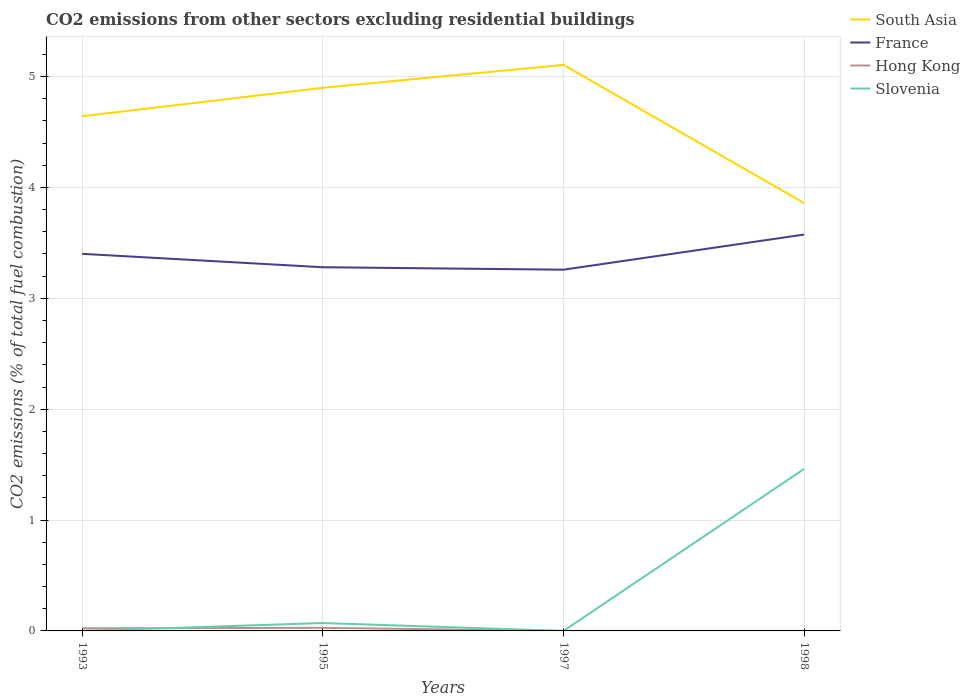How many different coloured lines are there?
Provide a succinct answer. 4. Does the line corresponding to Slovenia intersect with the line corresponding to South Asia?
Provide a short and direct response. No. Is the number of lines equal to the number of legend labels?
Provide a short and direct response. No. Across all years, what is the maximum total CO2 emitted in South Asia?
Provide a short and direct response. 3.86. What is the total total CO2 emitted in France in the graph?
Offer a very short reply. 0.14. What is the difference between the highest and the second highest total CO2 emitted in Slovenia?
Offer a very short reply. 1.46. Is the total CO2 emitted in South Asia strictly greater than the total CO2 emitted in Hong Kong over the years?
Your response must be concise. No. How many lines are there?
Ensure brevity in your answer.  4. How many years are there in the graph?
Offer a terse response. 4. How are the legend labels stacked?
Make the answer very short. Vertical. What is the title of the graph?
Your response must be concise. CO2 emissions from other sectors excluding residential buildings. What is the label or title of the Y-axis?
Your response must be concise. CO2 emissions (% of total fuel combustion). What is the CO2 emissions (% of total fuel combustion) in South Asia in 1993?
Your answer should be compact. 4.64. What is the CO2 emissions (% of total fuel combustion) of France in 1993?
Keep it short and to the point. 3.4. What is the CO2 emissions (% of total fuel combustion) of Hong Kong in 1993?
Your answer should be very brief. 0.02. What is the CO2 emissions (% of total fuel combustion) in Slovenia in 1993?
Provide a succinct answer. 8.47498492080272e-16. What is the CO2 emissions (% of total fuel combustion) of South Asia in 1995?
Make the answer very short. 4.9. What is the CO2 emissions (% of total fuel combustion) in France in 1995?
Offer a very short reply. 3.28. What is the CO2 emissions (% of total fuel combustion) in Hong Kong in 1995?
Your answer should be very brief. 0.03. What is the CO2 emissions (% of total fuel combustion) of Slovenia in 1995?
Keep it short and to the point. 0.07. What is the CO2 emissions (% of total fuel combustion) of South Asia in 1997?
Your response must be concise. 5.11. What is the CO2 emissions (% of total fuel combustion) of France in 1997?
Give a very brief answer. 3.26. What is the CO2 emissions (% of total fuel combustion) of Hong Kong in 1997?
Ensure brevity in your answer.  0. What is the CO2 emissions (% of total fuel combustion) in Slovenia in 1997?
Your response must be concise. 0. What is the CO2 emissions (% of total fuel combustion) in South Asia in 1998?
Your response must be concise. 3.86. What is the CO2 emissions (% of total fuel combustion) of France in 1998?
Your answer should be very brief. 3.58. What is the CO2 emissions (% of total fuel combustion) of Hong Kong in 1998?
Make the answer very short. 0. What is the CO2 emissions (% of total fuel combustion) of Slovenia in 1998?
Provide a succinct answer. 1.46. Across all years, what is the maximum CO2 emissions (% of total fuel combustion) in South Asia?
Make the answer very short. 5.11. Across all years, what is the maximum CO2 emissions (% of total fuel combustion) in France?
Offer a very short reply. 3.58. Across all years, what is the maximum CO2 emissions (% of total fuel combustion) in Hong Kong?
Your answer should be very brief. 0.03. Across all years, what is the maximum CO2 emissions (% of total fuel combustion) of Slovenia?
Give a very brief answer. 1.46. Across all years, what is the minimum CO2 emissions (% of total fuel combustion) of South Asia?
Your response must be concise. 3.86. Across all years, what is the minimum CO2 emissions (% of total fuel combustion) in France?
Your answer should be very brief. 3.26. What is the total CO2 emissions (% of total fuel combustion) in South Asia in the graph?
Offer a very short reply. 18.51. What is the total CO2 emissions (% of total fuel combustion) in France in the graph?
Keep it short and to the point. 13.51. What is the total CO2 emissions (% of total fuel combustion) in Hong Kong in the graph?
Offer a terse response. 0.05. What is the total CO2 emissions (% of total fuel combustion) of Slovenia in the graph?
Make the answer very short. 1.53. What is the difference between the CO2 emissions (% of total fuel combustion) of South Asia in 1993 and that in 1995?
Offer a very short reply. -0.26. What is the difference between the CO2 emissions (% of total fuel combustion) of France in 1993 and that in 1995?
Ensure brevity in your answer.  0.12. What is the difference between the CO2 emissions (% of total fuel combustion) of Hong Kong in 1993 and that in 1995?
Offer a very short reply. -0. What is the difference between the CO2 emissions (% of total fuel combustion) in Slovenia in 1993 and that in 1995?
Your response must be concise. -0.07. What is the difference between the CO2 emissions (% of total fuel combustion) in South Asia in 1993 and that in 1997?
Your answer should be very brief. -0.46. What is the difference between the CO2 emissions (% of total fuel combustion) in France in 1993 and that in 1997?
Provide a succinct answer. 0.14. What is the difference between the CO2 emissions (% of total fuel combustion) of South Asia in 1993 and that in 1998?
Offer a terse response. 0.78. What is the difference between the CO2 emissions (% of total fuel combustion) in France in 1993 and that in 1998?
Offer a very short reply. -0.17. What is the difference between the CO2 emissions (% of total fuel combustion) of Slovenia in 1993 and that in 1998?
Your answer should be very brief. -1.46. What is the difference between the CO2 emissions (% of total fuel combustion) in South Asia in 1995 and that in 1997?
Offer a very short reply. -0.21. What is the difference between the CO2 emissions (% of total fuel combustion) in France in 1995 and that in 1997?
Keep it short and to the point. 0.02. What is the difference between the CO2 emissions (% of total fuel combustion) in South Asia in 1995 and that in 1998?
Provide a short and direct response. 1.04. What is the difference between the CO2 emissions (% of total fuel combustion) in France in 1995 and that in 1998?
Provide a succinct answer. -0.29. What is the difference between the CO2 emissions (% of total fuel combustion) of Slovenia in 1995 and that in 1998?
Keep it short and to the point. -1.39. What is the difference between the CO2 emissions (% of total fuel combustion) in South Asia in 1997 and that in 1998?
Your answer should be compact. 1.25. What is the difference between the CO2 emissions (% of total fuel combustion) of France in 1997 and that in 1998?
Keep it short and to the point. -0.32. What is the difference between the CO2 emissions (% of total fuel combustion) in South Asia in 1993 and the CO2 emissions (% of total fuel combustion) in France in 1995?
Your answer should be very brief. 1.36. What is the difference between the CO2 emissions (% of total fuel combustion) of South Asia in 1993 and the CO2 emissions (% of total fuel combustion) of Hong Kong in 1995?
Your response must be concise. 4.61. What is the difference between the CO2 emissions (% of total fuel combustion) of South Asia in 1993 and the CO2 emissions (% of total fuel combustion) of Slovenia in 1995?
Offer a terse response. 4.57. What is the difference between the CO2 emissions (% of total fuel combustion) in France in 1993 and the CO2 emissions (% of total fuel combustion) in Hong Kong in 1995?
Keep it short and to the point. 3.37. What is the difference between the CO2 emissions (% of total fuel combustion) of France in 1993 and the CO2 emissions (% of total fuel combustion) of Slovenia in 1995?
Provide a succinct answer. 3.33. What is the difference between the CO2 emissions (% of total fuel combustion) in Hong Kong in 1993 and the CO2 emissions (% of total fuel combustion) in Slovenia in 1995?
Provide a succinct answer. -0.05. What is the difference between the CO2 emissions (% of total fuel combustion) of South Asia in 1993 and the CO2 emissions (% of total fuel combustion) of France in 1997?
Give a very brief answer. 1.38. What is the difference between the CO2 emissions (% of total fuel combustion) of South Asia in 1993 and the CO2 emissions (% of total fuel combustion) of France in 1998?
Provide a short and direct response. 1.07. What is the difference between the CO2 emissions (% of total fuel combustion) in South Asia in 1993 and the CO2 emissions (% of total fuel combustion) in Slovenia in 1998?
Offer a very short reply. 3.18. What is the difference between the CO2 emissions (% of total fuel combustion) of France in 1993 and the CO2 emissions (% of total fuel combustion) of Slovenia in 1998?
Make the answer very short. 1.94. What is the difference between the CO2 emissions (% of total fuel combustion) of Hong Kong in 1993 and the CO2 emissions (% of total fuel combustion) of Slovenia in 1998?
Offer a very short reply. -1.44. What is the difference between the CO2 emissions (% of total fuel combustion) of South Asia in 1995 and the CO2 emissions (% of total fuel combustion) of France in 1997?
Offer a terse response. 1.64. What is the difference between the CO2 emissions (% of total fuel combustion) of South Asia in 1995 and the CO2 emissions (% of total fuel combustion) of France in 1998?
Offer a very short reply. 1.32. What is the difference between the CO2 emissions (% of total fuel combustion) of South Asia in 1995 and the CO2 emissions (% of total fuel combustion) of Slovenia in 1998?
Provide a short and direct response. 3.44. What is the difference between the CO2 emissions (% of total fuel combustion) of France in 1995 and the CO2 emissions (% of total fuel combustion) of Slovenia in 1998?
Provide a succinct answer. 1.82. What is the difference between the CO2 emissions (% of total fuel combustion) in Hong Kong in 1995 and the CO2 emissions (% of total fuel combustion) in Slovenia in 1998?
Your response must be concise. -1.43. What is the difference between the CO2 emissions (% of total fuel combustion) in South Asia in 1997 and the CO2 emissions (% of total fuel combustion) in France in 1998?
Your response must be concise. 1.53. What is the difference between the CO2 emissions (% of total fuel combustion) in South Asia in 1997 and the CO2 emissions (% of total fuel combustion) in Slovenia in 1998?
Your answer should be very brief. 3.64. What is the difference between the CO2 emissions (% of total fuel combustion) in France in 1997 and the CO2 emissions (% of total fuel combustion) in Slovenia in 1998?
Provide a short and direct response. 1.8. What is the average CO2 emissions (% of total fuel combustion) in South Asia per year?
Offer a very short reply. 4.63. What is the average CO2 emissions (% of total fuel combustion) of France per year?
Your answer should be compact. 3.38. What is the average CO2 emissions (% of total fuel combustion) in Hong Kong per year?
Provide a short and direct response. 0.01. What is the average CO2 emissions (% of total fuel combustion) in Slovenia per year?
Keep it short and to the point. 0.38. In the year 1993, what is the difference between the CO2 emissions (% of total fuel combustion) in South Asia and CO2 emissions (% of total fuel combustion) in France?
Make the answer very short. 1.24. In the year 1993, what is the difference between the CO2 emissions (% of total fuel combustion) in South Asia and CO2 emissions (% of total fuel combustion) in Hong Kong?
Offer a very short reply. 4.62. In the year 1993, what is the difference between the CO2 emissions (% of total fuel combustion) in South Asia and CO2 emissions (% of total fuel combustion) in Slovenia?
Your answer should be compact. 4.64. In the year 1993, what is the difference between the CO2 emissions (% of total fuel combustion) in France and CO2 emissions (% of total fuel combustion) in Hong Kong?
Offer a very short reply. 3.38. In the year 1993, what is the difference between the CO2 emissions (% of total fuel combustion) in France and CO2 emissions (% of total fuel combustion) in Slovenia?
Provide a succinct answer. 3.4. In the year 1993, what is the difference between the CO2 emissions (% of total fuel combustion) in Hong Kong and CO2 emissions (% of total fuel combustion) in Slovenia?
Keep it short and to the point. 0.02. In the year 1995, what is the difference between the CO2 emissions (% of total fuel combustion) in South Asia and CO2 emissions (% of total fuel combustion) in France?
Ensure brevity in your answer.  1.62. In the year 1995, what is the difference between the CO2 emissions (% of total fuel combustion) in South Asia and CO2 emissions (% of total fuel combustion) in Hong Kong?
Offer a very short reply. 4.87. In the year 1995, what is the difference between the CO2 emissions (% of total fuel combustion) of South Asia and CO2 emissions (% of total fuel combustion) of Slovenia?
Provide a succinct answer. 4.83. In the year 1995, what is the difference between the CO2 emissions (% of total fuel combustion) of France and CO2 emissions (% of total fuel combustion) of Hong Kong?
Your answer should be very brief. 3.25. In the year 1995, what is the difference between the CO2 emissions (% of total fuel combustion) of France and CO2 emissions (% of total fuel combustion) of Slovenia?
Your answer should be very brief. 3.21. In the year 1995, what is the difference between the CO2 emissions (% of total fuel combustion) of Hong Kong and CO2 emissions (% of total fuel combustion) of Slovenia?
Provide a short and direct response. -0.04. In the year 1997, what is the difference between the CO2 emissions (% of total fuel combustion) of South Asia and CO2 emissions (% of total fuel combustion) of France?
Ensure brevity in your answer.  1.85. In the year 1998, what is the difference between the CO2 emissions (% of total fuel combustion) in South Asia and CO2 emissions (% of total fuel combustion) in France?
Provide a short and direct response. 0.28. In the year 1998, what is the difference between the CO2 emissions (% of total fuel combustion) of South Asia and CO2 emissions (% of total fuel combustion) of Slovenia?
Ensure brevity in your answer.  2.4. In the year 1998, what is the difference between the CO2 emissions (% of total fuel combustion) of France and CO2 emissions (% of total fuel combustion) of Slovenia?
Offer a very short reply. 2.11. What is the ratio of the CO2 emissions (% of total fuel combustion) in South Asia in 1993 to that in 1995?
Your response must be concise. 0.95. What is the ratio of the CO2 emissions (% of total fuel combustion) in France in 1993 to that in 1995?
Offer a terse response. 1.04. What is the ratio of the CO2 emissions (% of total fuel combustion) in Hong Kong in 1993 to that in 1995?
Offer a very short reply. 0.85. What is the ratio of the CO2 emissions (% of total fuel combustion) in Slovenia in 1993 to that in 1995?
Your answer should be very brief. 0. What is the ratio of the CO2 emissions (% of total fuel combustion) in South Asia in 1993 to that in 1997?
Give a very brief answer. 0.91. What is the ratio of the CO2 emissions (% of total fuel combustion) in France in 1993 to that in 1997?
Keep it short and to the point. 1.04. What is the ratio of the CO2 emissions (% of total fuel combustion) of South Asia in 1993 to that in 1998?
Give a very brief answer. 1.2. What is the ratio of the CO2 emissions (% of total fuel combustion) in France in 1993 to that in 1998?
Offer a terse response. 0.95. What is the ratio of the CO2 emissions (% of total fuel combustion) of South Asia in 1995 to that in 1997?
Offer a terse response. 0.96. What is the ratio of the CO2 emissions (% of total fuel combustion) in France in 1995 to that in 1997?
Your answer should be very brief. 1.01. What is the ratio of the CO2 emissions (% of total fuel combustion) in South Asia in 1995 to that in 1998?
Offer a terse response. 1.27. What is the ratio of the CO2 emissions (% of total fuel combustion) of France in 1995 to that in 1998?
Provide a short and direct response. 0.92. What is the ratio of the CO2 emissions (% of total fuel combustion) in Slovenia in 1995 to that in 1998?
Give a very brief answer. 0.05. What is the ratio of the CO2 emissions (% of total fuel combustion) in South Asia in 1997 to that in 1998?
Keep it short and to the point. 1.32. What is the ratio of the CO2 emissions (% of total fuel combustion) of France in 1997 to that in 1998?
Your response must be concise. 0.91. What is the difference between the highest and the second highest CO2 emissions (% of total fuel combustion) in South Asia?
Provide a succinct answer. 0.21. What is the difference between the highest and the second highest CO2 emissions (% of total fuel combustion) of France?
Your answer should be compact. 0.17. What is the difference between the highest and the second highest CO2 emissions (% of total fuel combustion) in Slovenia?
Offer a very short reply. 1.39. What is the difference between the highest and the lowest CO2 emissions (% of total fuel combustion) in South Asia?
Offer a very short reply. 1.25. What is the difference between the highest and the lowest CO2 emissions (% of total fuel combustion) of France?
Ensure brevity in your answer.  0.32. What is the difference between the highest and the lowest CO2 emissions (% of total fuel combustion) in Hong Kong?
Keep it short and to the point. 0.03. What is the difference between the highest and the lowest CO2 emissions (% of total fuel combustion) in Slovenia?
Provide a short and direct response. 1.46. 